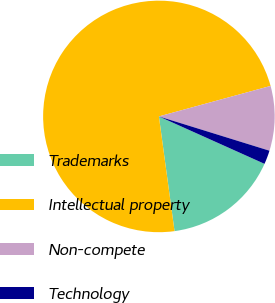Convert chart to OTSL. <chart><loc_0><loc_0><loc_500><loc_500><pie_chart><fcel>Trademarks<fcel>Intellectual property<fcel>Non-compete<fcel>Technology<nl><fcel>16.13%<fcel>72.92%<fcel>9.03%<fcel>1.93%<nl></chart> 